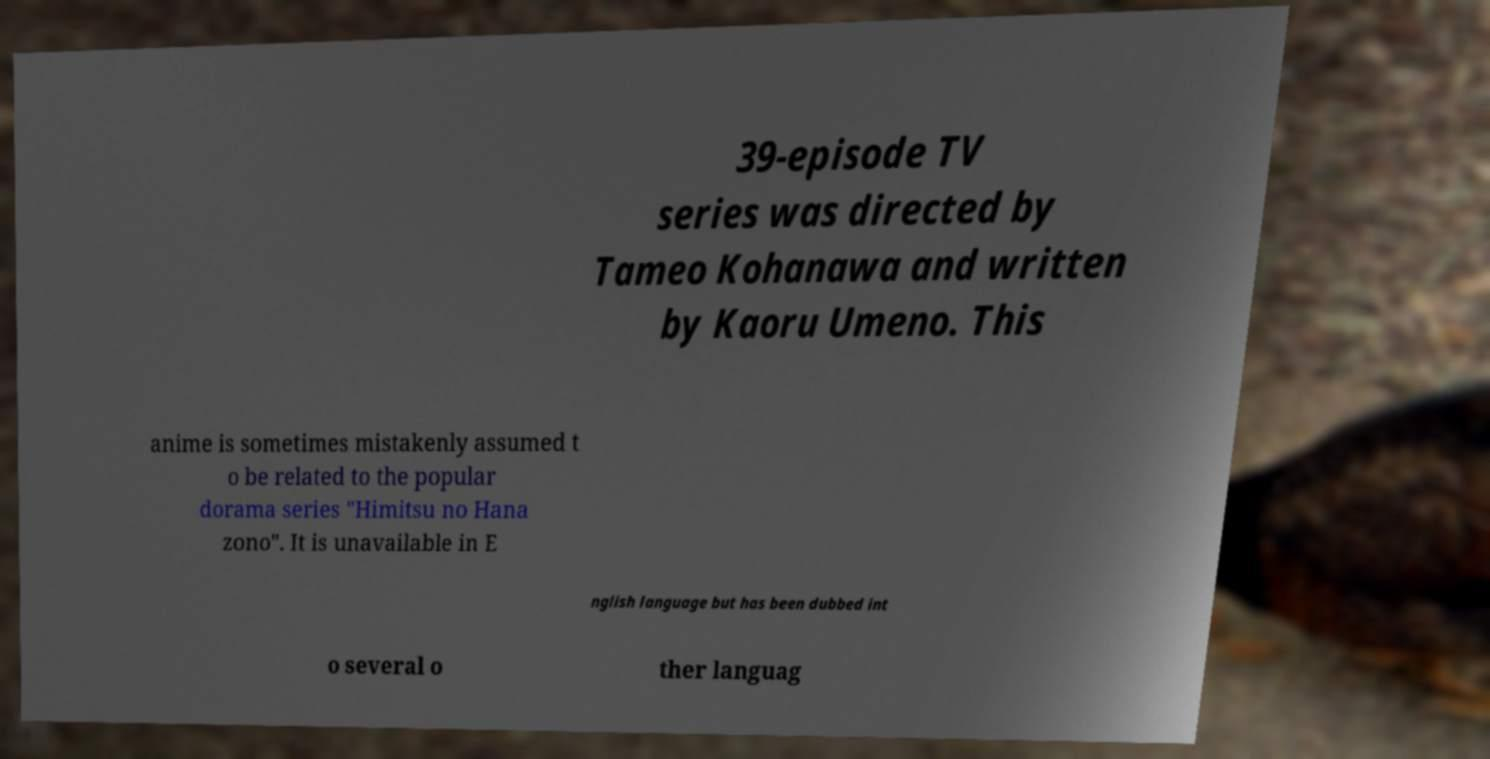Please read and relay the text visible in this image. What does it say? 39-episode TV series was directed by Tameo Kohanawa and written by Kaoru Umeno. This anime is sometimes mistakenly assumed t o be related to the popular dorama series "Himitsu no Hana zono". It is unavailable in E nglish language but has been dubbed int o several o ther languag 